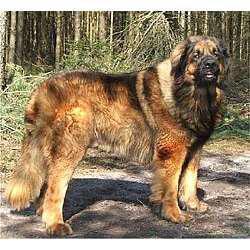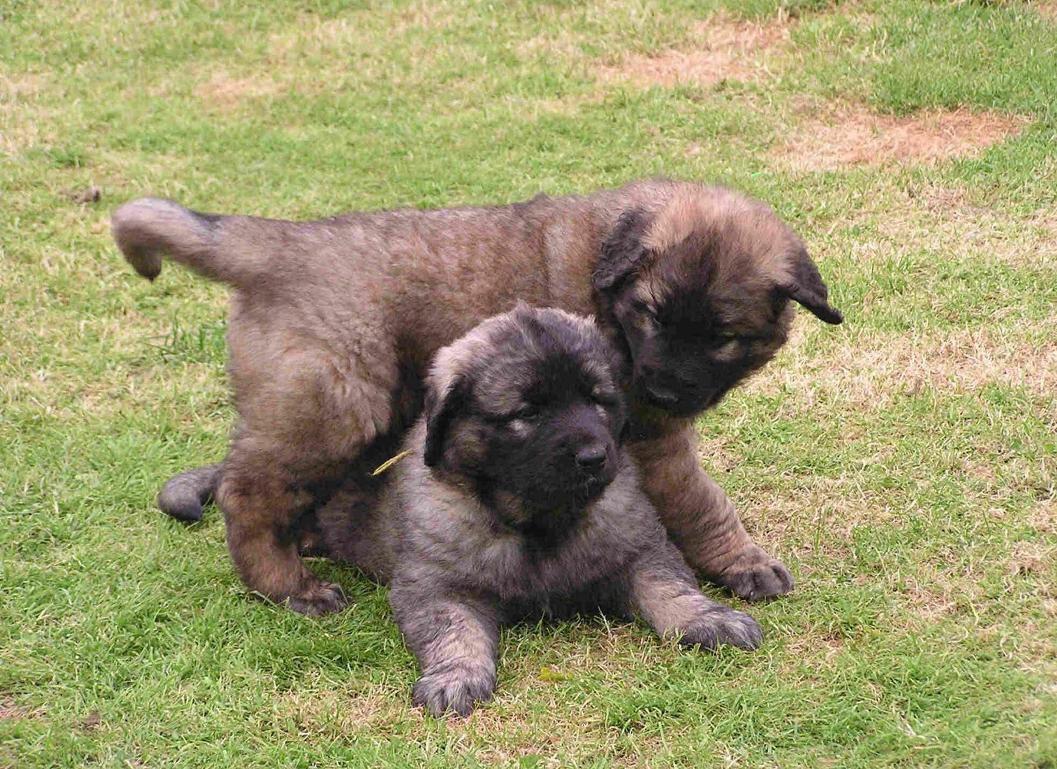The first image is the image on the left, the second image is the image on the right. Considering the images on both sides, is "We've got two dogs here." valid? Answer yes or no. No. The first image is the image on the left, the second image is the image on the right. Analyze the images presented: Is the assertion "There are at least three fluffy black and tan dogs." valid? Answer yes or no. Yes. 